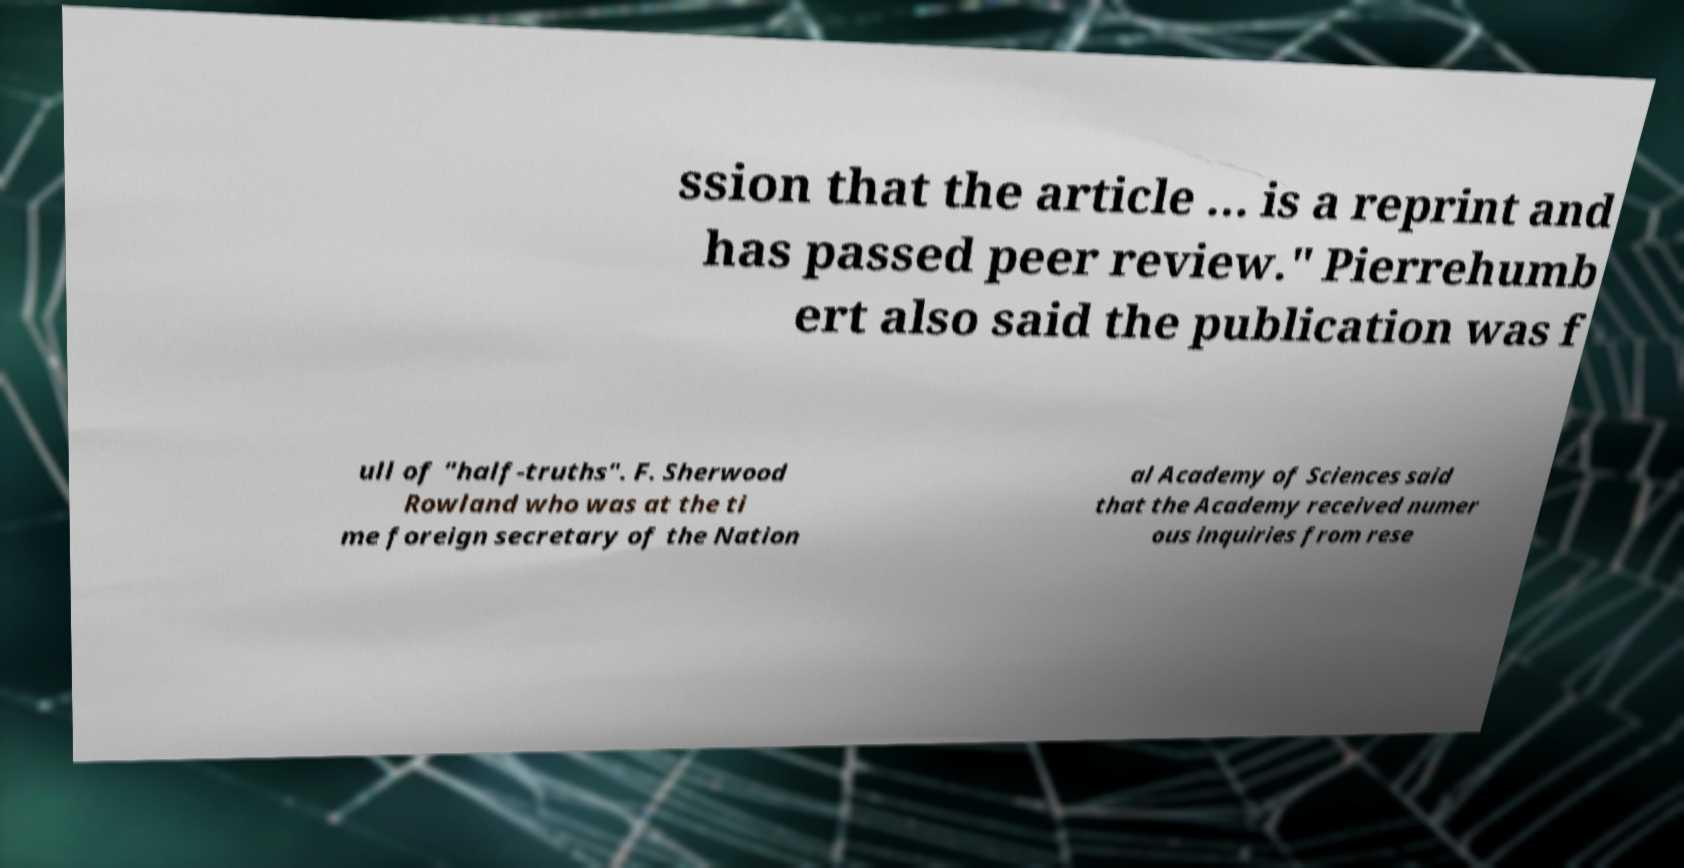Could you assist in decoding the text presented in this image and type it out clearly? ssion that the article … is a reprint and has passed peer review." Pierrehumb ert also said the publication was f ull of "half-truths". F. Sherwood Rowland who was at the ti me foreign secretary of the Nation al Academy of Sciences said that the Academy received numer ous inquiries from rese 